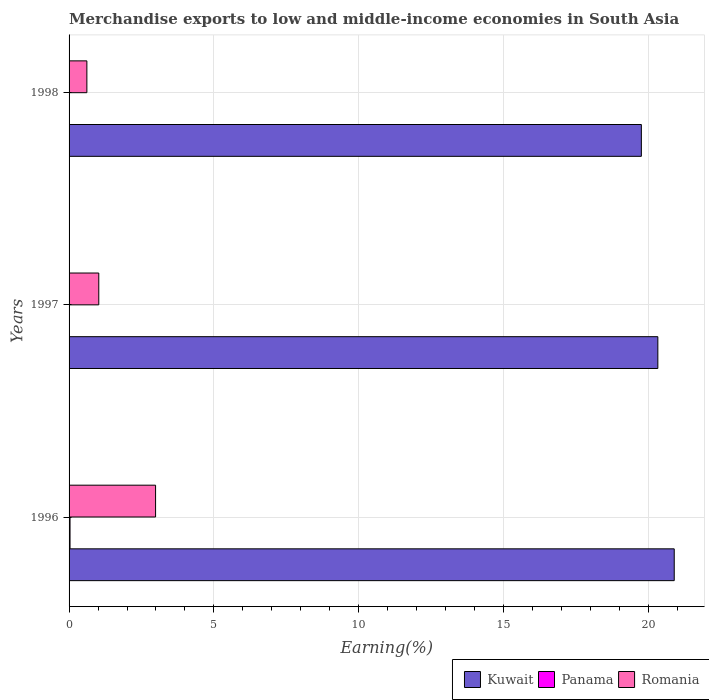How many different coloured bars are there?
Provide a succinct answer. 3. How many groups of bars are there?
Provide a succinct answer. 3. Are the number of bars per tick equal to the number of legend labels?
Give a very brief answer. Yes. In how many cases, is the number of bars for a given year not equal to the number of legend labels?
Your response must be concise. 0. What is the percentage of amount earned from merchandise exports in Panama in 1998?
Your response must be concise. 0.01. Across all years, what is the maximum percentage of amount earned from merchandise exports in Kuwait?
Your answer should be very brief. 20.89. Across all years, what is the minimum percentage of amount earned from merchandise exports in Romania?
Ensure brevity in your answer.  0.61. In which year was the percentage of amount earned from merchandise exports in Romania maximum?
Give a very brief answer. 1996. In which year was the percentage of amount earned from merchandise exports in Romania minimum?
Your response must be concise. 1998. What is the total percentage of amount earned from merchandise exports in Romania in the graph?
Ensure brevity in your answer.  4.63. What is the difference between the percentage of amount earned from merchandise exports in Romania in 1996 and that in 1998?
Your answer should be very brief. 2.37. What is the difference between the percentage of amount earned from merchandise exports in Kuwait in 1996 and the percentage of amount earned from merchandise exports in Romania in 1997?
Offer a terse response. 19.87. What is the average percentage of amount earned from merchandise exports in Kuwait per year?
Offer a very short reply. 20.32. In the year 1997, what is the difference between the percentage of amount earned from merchandise exports in Kuwait and percentage of amount earned from merchandise exports in Romania?
Your answer should be very brief. 19.3. In how many years, is the percentage of amount earned from merchandise exports in Romania greater than 16 %?
Your answer should be compact. 0. What is the ratio of the percentage of amount earned from merchandise exports in Kuwait in 1996 to that in 1998?
Keep it short and to the point. 1.06. Is the percentage of amount earned from merchandise exports in Panama in 1997 less than that in 1998?
Make the answer very short. Yes. What is the difference between the highest and the second highest percentage of amount earned from merchandise exports in Panama?
Provide a short and direct response. 0.02. What is the difference between the highest and the lowest percentage of amount earned from merchandise exports in Panama?
Provide a short and direct response. 0.03. In how many years, is the percentage of amount earned from merchandise exports in Romania greater than the average percentage of amount earned from merchandise exports in Romania taken over all years?
Give a very brief answer. 1. What does the 1st bar from the top in 1996 represents?
Your response must be concise. Romania. What does the 3rd bar from the bottom in 1996 represents?
Keep it short and to the point. Romania. How many bars are there?
Your answer should be compact. 9. Are all the bars in the graph horizontal?
Give a very brief answer. Yes. Are the values on the major ticks of X-axis written in scientific E-notation?
Your answer should be very brief. No. Does the graph contain grids?
Your answer should be compact. Yes. Where does the legend appear in the graph?
Make the answer very short. Bottom right. How many legend labels are there?
Your response must be concise. 3. How are the legend labels stacked?
Ensure brevity in your answer.  Horizontal. What is the title of the graph?
Your answer should be compact. Merchandise exports to low and middle-income economies in South Asia. Does "Middle East & North Africa (all income levels)" appear as one of the legend labels in the graph?
Your response must be concise. No. What is the label or title of the X-axis?
Your response must be concise. Earning(%). What is the label or title of the Y-axis?
Offer a terse response. Years. What is the Earning(%) of Kuwait in 1996?
Your answer should be compact. 20.89. What is the Earning(%) of Panama in 1996?
Offer a terse response. 0.03. What is the Earning(%) in Romania in 1996?
Provide a short and direct response. 2.99. What is the Earning(%) of Kuwait in 1997?
Ensure brevity in your answer.  20.33. What is the Earning(%) in Panama in 1997?
Keep it short and to the point. 0. What is the Earning(%) in Romania in 1997?
Provide a succinct answer. 1.03. What is the Earning(%) in Kuwait in 1998?
Your response must be concise. 19.76. What is the Earning(%) in Panama in 1998?
Offer a very short reply. 0.01. What is the Earning(%) of Romania in 1998?
Offer a very short reply. 0.61. Across all years, what is the maximum Earning(%) of Kuwait?
Your answer should be compact. 20.89. Across all years, what is the maximum Earning(%) of Panama?
Ensure brevity in your answer.  0.03. Across all years, what is the maximum Earning(%) in Romania?
Provide a succinct answer. 2.99. Across all years, what is the minimum Earning(%) in Kuwait?
Make the answer very short. 19.76. Across all years, what is the minimum Earning(%) of Panama?
Give a very brief answer. 0. Across all years, what is the minimum Earning(%) in Romania?
Keep it short and to the point. 0.61. What is the total Earning(%) of Kuwait in the graph?
Your response must be concise. 60.97. What is the total Earning(%) of Panama in the graph?
Your answer should be very brief. 0.05. What is the total Earning(%) in Romania in the graph?
Your answer should be compact. 4.63. What is the difference between the Earning(%) in Kuwait in 1996 and that in 1997?
Keep it short and to the point. 0.57. What is the difference between the Earning(%) in Panama in 1996 and that in 1997?
Provide a short and direct response. 0.03. What is the difference between the Earning(%) of Romania in 1996 and that in 1997?
Keep it short and to the point. 1.96. What is the difference between the Earning(%) of Kuwait in 1996 and that in 1998?
Your response must be concise. 1.13. What is the difference between the Earning(%) in Panama in 1996 and that in 1998?
Offer a terse response. 0.02. What is the difference between the Earning(%) of Romania in 1996 and that in 1998?
Give a very brief answer. 2.37. What is the difference between the Earning(%) in Kuwait in 1997 and that in 1998?
Ensure brevity in your answer.  0.57. What is the difference between the Earning(%) in Panama in 1997 and that in 1998?
Ensure brevity in your answer.  -0.01. What is the difference between the Earning(%) of Romania in 1997 and that in 1998?
Ensure brevity in your answer.  0.41. What is the difference between the Earning(%) in Kuwait in 1996 and the Earning(%) in Panama in 1997?
Offer a very short reply. 20.89. What is the difference between the Earning(%) in Kuwait in 1996 and the Earning(%) in Romania in 1997?
Keep it short and to the point. 19.87. What is the difference between the Earning(%) in Panama in 1996 and the Earning(%) in Romania in 1997?
Ensure brevity in your answer.  -0.99. What is the difference between the Earning(%) in Kuwait in 1996 and the Earning(%) in Panama in 1998?
Keep it short and to the point. 20.88. What is the difference between the Earning(%) of Kuwait in 1996 and the Earning(%) of Romania in 1998?
Give a very brief answer. 20.28. What is the difference between the Earning(%) of Panama in 1996 and the Earning(%) of Romania in 1998?
Your response must be concise. -0.58. What is the difference between the Earning(%) in Kuwait in 1997 and the Earning(%) in Panama in 1998?
Ensure brevity in your answer.  20.31. What is the difference between the Earning(%) in Kuwait in 1997 and the Earning(%) in Romania in 1998?
Provide a short and direct response. 19.71. What is the difference between the Earning(%) in Panama in 1997 and the Earning(%) in Romania in 1998?
Offer a very short reply. -0.61. What is the average Earning(%) in Kuwait per year?
Make the answer very short. 20.32. What is the average Earning(%) of Panama per year?
Ensure brevity in your answer.  0.02. What is the average Earning(%) of Romania per year?
Keep it short and to the point. 1.54. In the year 1996, what is the difference between the Earning(%) in Kuwait and Earning(%) in Panama?
Ensure brevity in your answer.  20.86. In the year 1996, what is the difference between the Earning(%) in Kuwait and Earning(%) in Romania?
Offer a terse response. 17.9. In the year 1996, what is the difference between the Earning(%) in Panama and Earning(%) in Romania?
Offer a very short reply. -2.95. In the year 1997, what is the difference between the Earning(%) of Kuwait and Earning(%) of Panama?
Provide a short and direct response. 20.32. In the year 1997, what is the difference between the Earning(%) of Kuwait and Earning(%) of Romania?
Offer a terse response. 19.3. In the year 1997, what is the difference between the Earning(%) of Panama and Earning(%) of Romania?
Your answer should be compact. -1.02. In the year 1998, what is the difference between the Earning(%) in Kuwait and Earning(%) in Panama?
Make the answer very short. 19.75. In the year 1998, what is the difference between the Earning(%) of Kuwait and Earning(%) of Romania?
Offer a very short reply. 19.14. In the year 1998, what is the difference between the Earning(%) in Panama and Earning(%) in Romania?
Give a very brief answer. -0.6. What is the ratio of the Earning(%) of Kuwait in 1996 to that in 1997?
Give a very brief answer. 1.03. What is the ratio of the Earning(%) of Panama in 1996 to that in 1997?
Your response must be concise. 10.31. What is the ratio of the Earning(%) in Romania in 1996 to that in 1997?
Provide a short and direct response. 2.91. What is the ratio of the Earning(%) in Kuwait in 1996 to that in 1998?
Offer a terse response. 1.06. What is the ratio of the Earning(%) of Panama in 1996 to that in 1998?
Keep it short and to the point. 2.95. What is the ratio of the Earning(%) in Romania in 1996 to that in 1998?
Your answer should be compact. 4.86. What is the ratio of the Earning(%) of Kuwait in 1997 to that in 1998?
Give a very brief answer. 1.03. What is the ratio of the Earning(%) in Panama in 1997 to that in 1998?
Offer a very short reply. 0.29. What is the ratio of the Earning(%) in Romania in 1997 to that in 1998?
Your answer should be very brief. 1.67. What is the difference between the highest and the second highest Earning(%) in Kuwait?
Offer a terse response. 0.57. What is the difference between the highest and the second highest Earning(%) of Panama?
Your answer should be compact. 0.02. What is the difference between the highest and the second highest Earning(%) of Romania?
Keep it short and to the point. 1.96. What is the difference between the highest and the lowest Earning(%) of Kuwait?
Your answer should be compact. 1.13. What is the difference between the highest and the lowest Earning(%) of Romania?
Offer a very short reply. 2.37. 